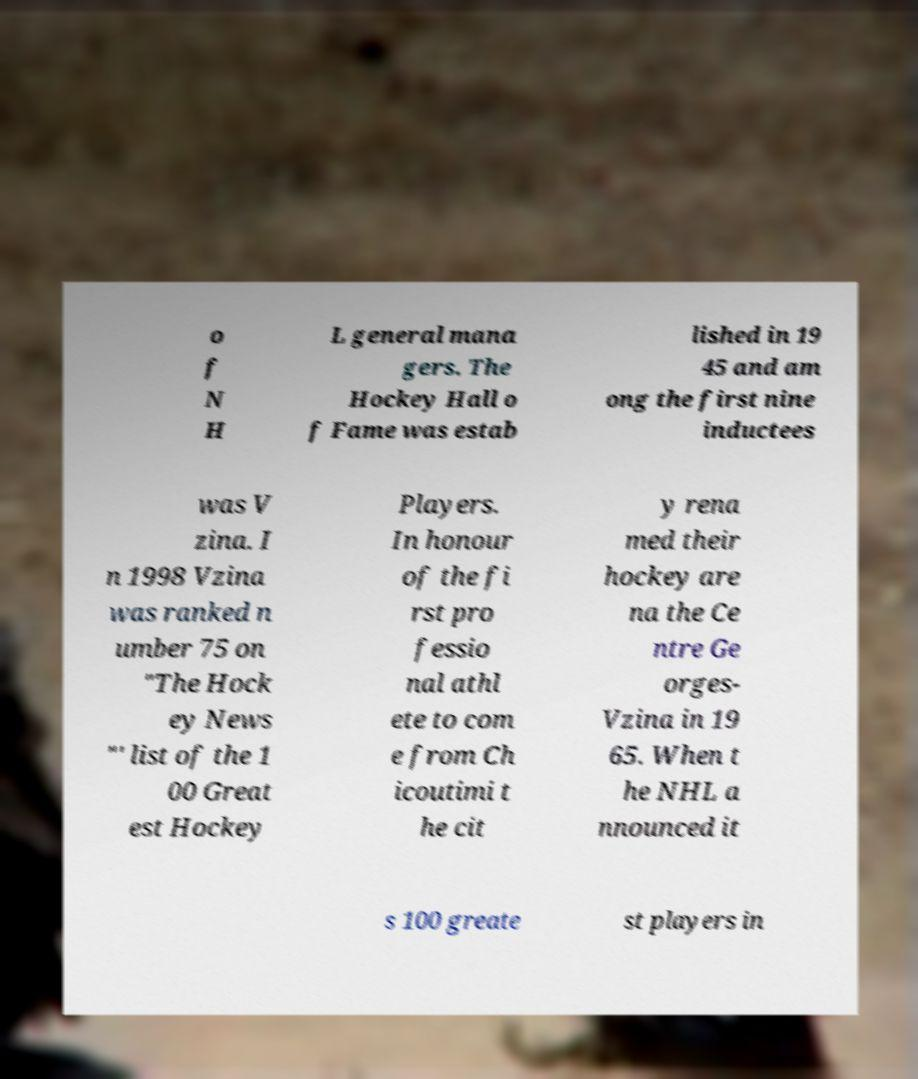For documentation purposes, I need the text within this image transcribed. Could you provide that? o f N H L general mana gers. The Hockey Hall o f Fame was estab lished in 19 45 and am ong the first nine inductees was V zina. I n 1998 Vzina was ranked n umber 75 on "The Hock ey News "' list of the 1 00 Great est Hockey Players. In honour of the fi rst pro fessio nal athl ete to com e from Ch icoutimi t he cit y rena med their hockey are na the Ce ntre Ge orges- Vzina in 19 65. When t he NHL a nnounced it s 100 greate st players in 